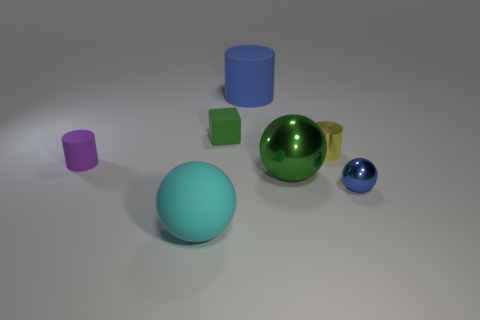Subtract all big cylinders. How many cylinders are left? 2 Subtract 1 blocks. How many blocks are left? 0 Subtract all yellow cylinders. How many cylinders are left? 2 Add 1 green matte objects. How many objects exist? 8 Subtract 1 green spheres. How many objects are left? 6 Subtract all cylinders. How many objects are left? 4 Subtract all blue blocks. Subtract all yellow cylinders. How many blocks are left? 1 Subtract all blue shiny spheres. Subtract all matte cylinders. How many objects are left? 4 Add 5 green shiny things. How many green shiny things are left? 6 Add 4 large cyan metal cylinders. How many large cyan metal cylinders exist? 4 